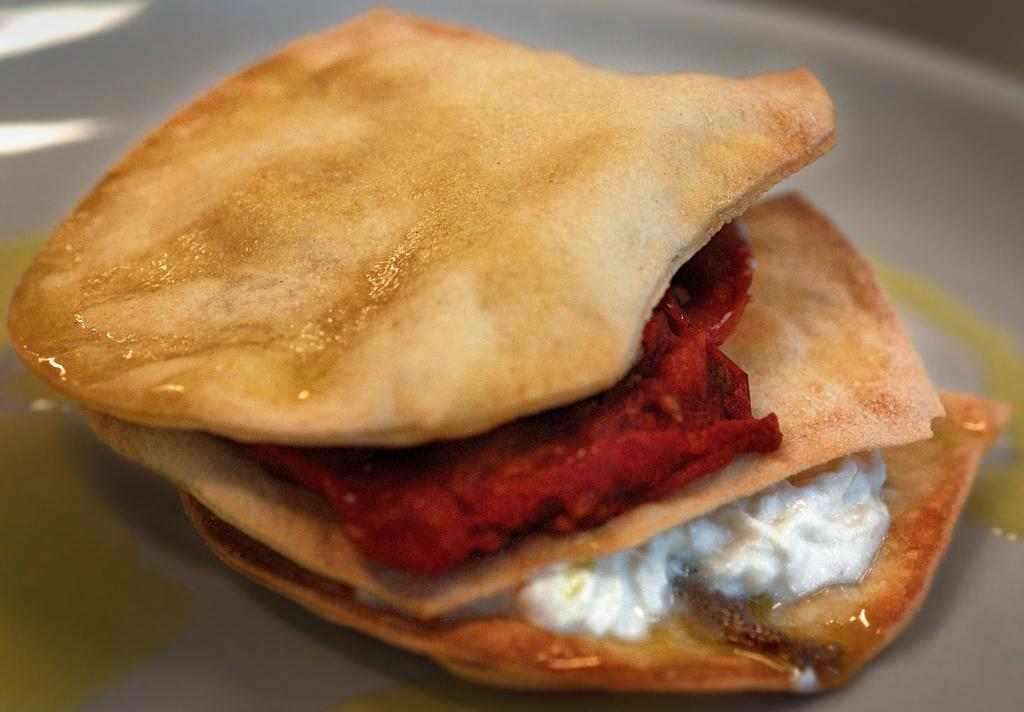What type of food can be seen in the image? There is a fast food item in the image. How is the fast food item presented? The fast food item is on a plate. What type of mint can be seen growing near the mailbox in the image? There is no mint or mailbox present in the image; it only features a fast food item on a plate. 